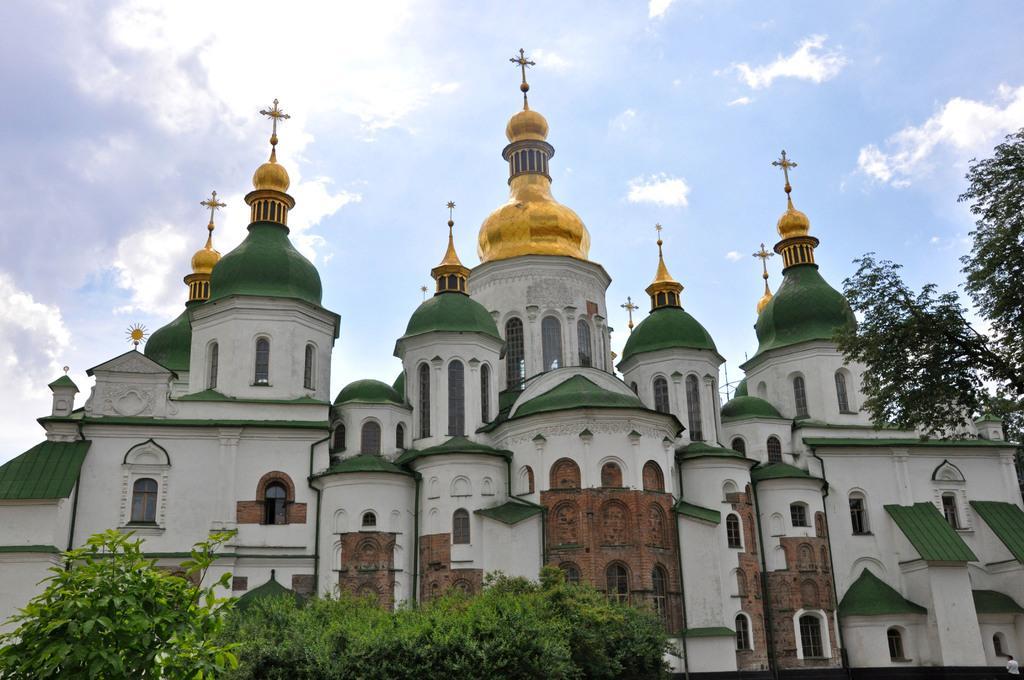Please provide a concise description of this image. In this image in the front there are trees. In the background there is a church and the sky is cloudy. 